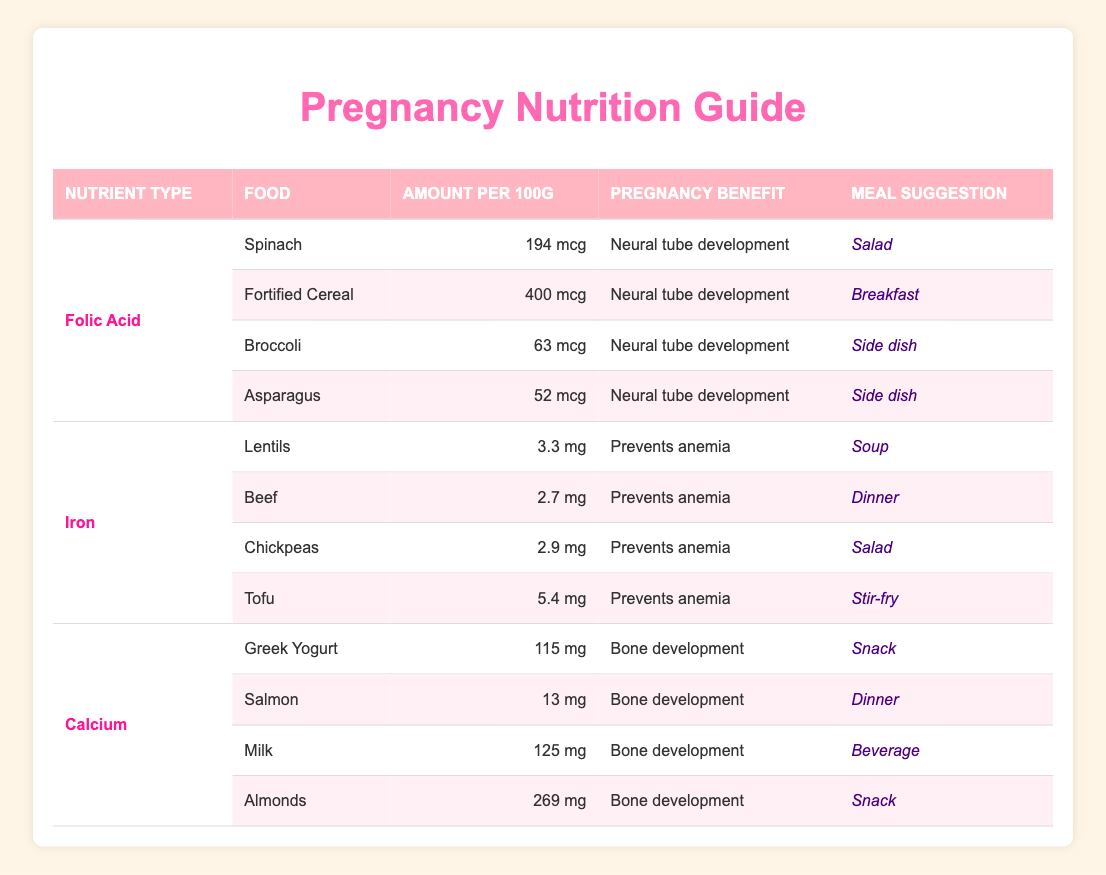What food has the highest amount of folic acid per 100g? Looking at the table, Fortified Cereal has the highest amount listed at 400 mcg per 100g.
Answer: Fortified Cereal Which food offers the most iron for pregnancy? Among all the foods listed, Tofu provides the highest iron content at 5.4 mg per 100g.
Answer: Tofu Is it true that Milk contains more calcium than Salmon? Comparing the calcium content, Milk has 125 mg and Salmon has 13 mg. Thus, it is true that Milk contains more calcium than Salmon.
Answer: Yes What is the total amount of iron provided by Lentils and Chickpeas combined? Lentils provide 3.3 mg and Chickpeas provide 2.9 mg. Adding these gives 3.3 + 2.9 = 6.2 mg of iron combined.
Answer: 6.2 mg Which foods are recommended for neural tube development in pregnancy? The foods recommended for neural tube development, which is related to folic acid, include Spinach, Fortified Cereal, Broccoli, and Asparagus.
Answer: Spinach, Fortified Cereal, Broccoli, Asparagus What is the average amount of calcium in the listed foods? The foods rich in calcium are Greek Yogurt (115 mg), Salmon (13 mg), Milk (125 mg), and Almonds (269 mg). Adding these amounts gives 115 + 13 + 125 + 269 = 522 mg. To find the average, divide by 4: 522/4 = 130.5.
Answer: 130.5 mg How many foods in the table suggest salad as a meal? The table shows that both Spinach and Chickpeas are suggested to be used in a salad, totaling 2 foods that suggest salad.
Answer: 2 Which nutrient type has the least amount listed in the table? Looking at the table, Salmon has the least amount of any nutrient listed, providing only 13 mg of calcium.
Answer: Calcium Is there any food that suggests soup as a meal? Yes, the table indicates that Lentils suggest soup as a meal option, confirming the existence of such a meal suggestion.
Answer: Yes 